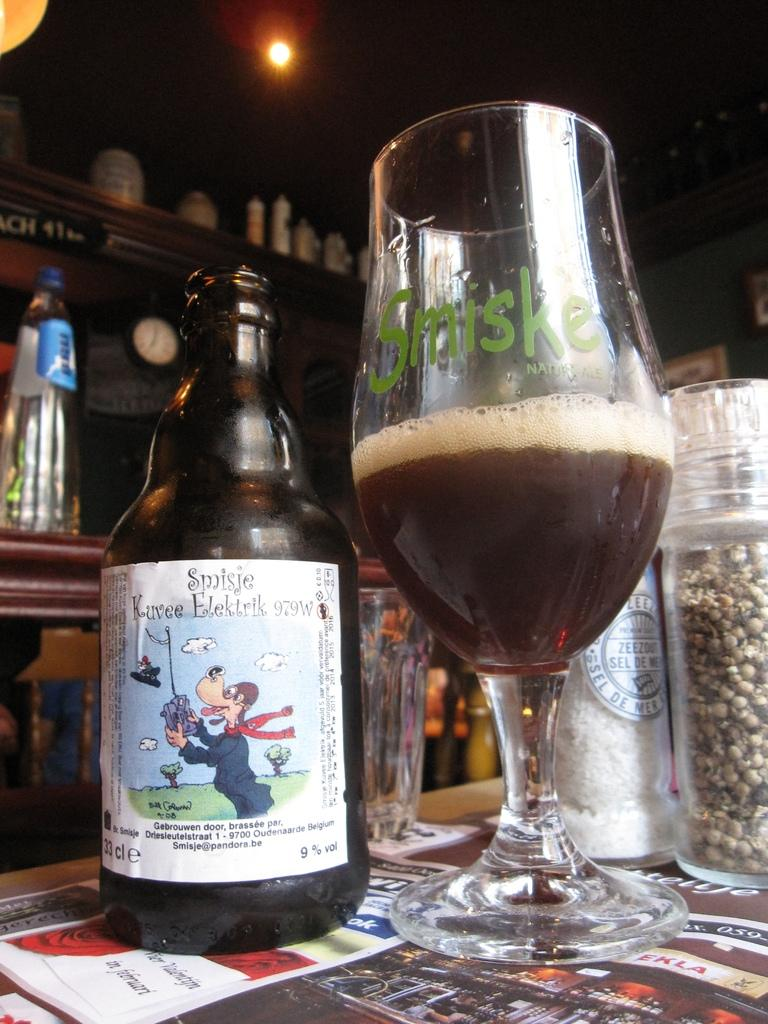What is on the table in the image? There is a wine bottle and a glass on the table. What else can be seen in the image besides the table? In the background, there are bottles and a light. How many drawers are visible in the image? There are no drawers present in the image. What type of temper is the wine bottle displaying in the image? The wine bottle does not have a temper, as it is an inanimate object. 